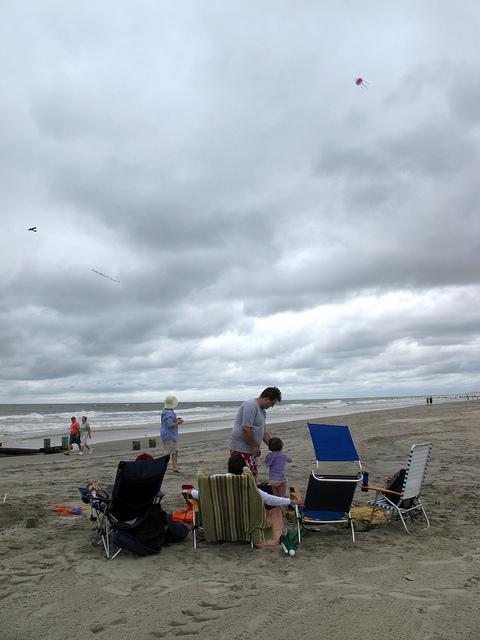How many chairs are there?
Give a very brief answer. 5. 